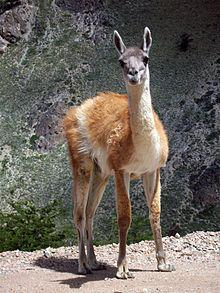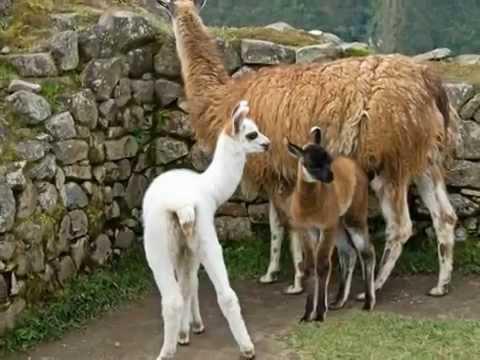The first image is the image on the left, the second image is the image on the right. Given the left and right images, does the statement "In at least one image there is a baby white llama to the side of its brown mother." hold true? Answer yes or no. Yes. The first image is the image on the left, the second image is the image on the right. For the images displayed, is the sentence "The right image includes a small white llama bending its neck toward a bigger shaggy reddish-brown llama." factually correct? Answer yes or no. Yes. 